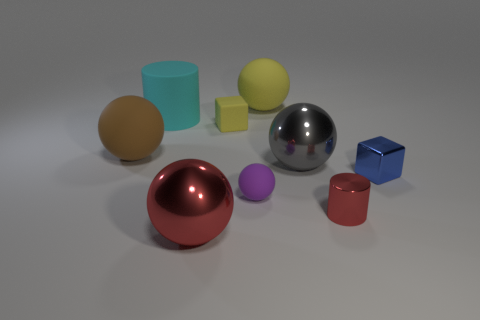The rubber object that is the same shape as the blue metal object is what color?
Give a very brief answer. Yellow. Are there more big gray objects behind the blue cube than brown rubber objects?
Give a very brief answer. No. There is a small thing that is behind the shiny cube; what is its color?
Your answer should be very brief. Yellow. Do the yellow rubber ball and the blue cube have the same size?
Your answer should be compact. No. What is the size of the purple sphere?
Make the answer very short. Small. Is the number of big yellow rubber things greater than the number of large purple matte spheres?
Provide a succinct answer. Yes. The large rubber ball in front of the large matte ball that is right of the large rubber ball that is to the left of the big yellow object is what color?
Give a very brief answer. Brown. There is a small rubber thing that is in front of the tiny blue metal thing; is its shape the same as the large brown matte thing?
Your answer should be compact. Yes. There is a matte ball that is the same size as the red cylinder; what is its color?
Your answer should be compact. Purple. How many purple rubber things are there?
Your answer should be compact. 1. 